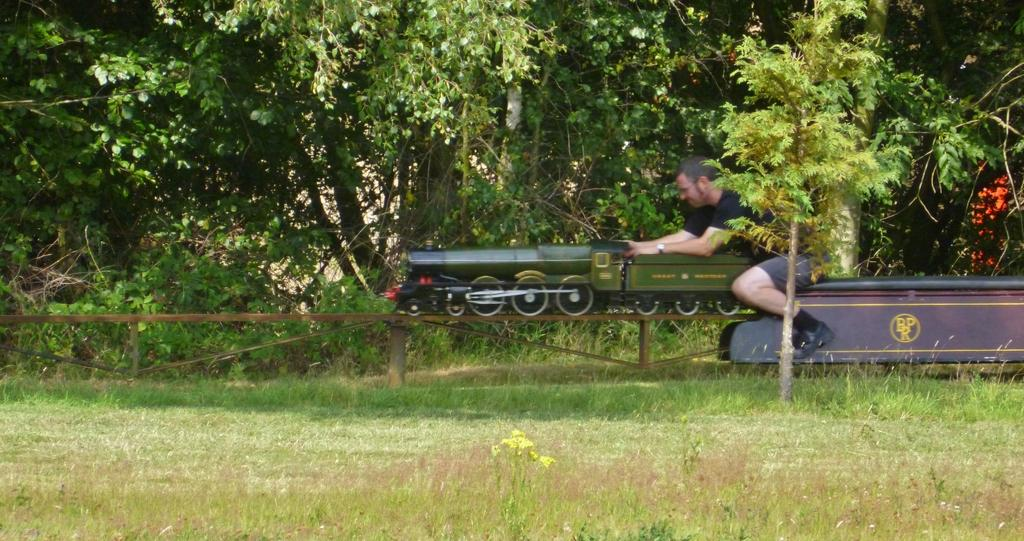What is the main subject of the image? The main subject of the image is a toy train. What is the toy train doing in the image? The toy train is on a track. What color is the toy train? The toy train is green in color. Is there anyone on the toy train? Yes, there is a person sitting on the train. What can be seen in the background of the image? There are trees in the background of the image. What type of advice is the person on the train giving to the trees in the background? There is no indication in the image that the person on the train is giving advice to the trees, nor is there any dialogue present. 